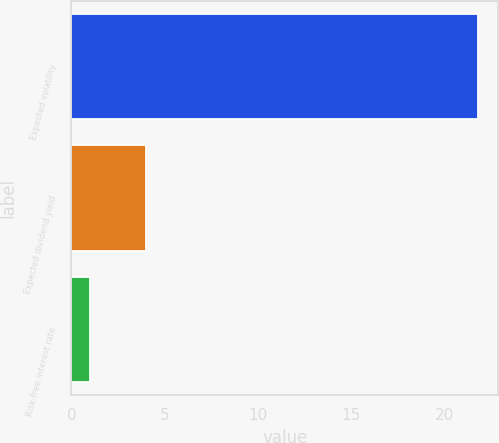<chart> <loc_0><loc_0><loc_500><loc_500><bar_chart><fcel>Expected volatility<fcel>Expected dividend yield<fcel>Risk-free interest rate<nl><fcel>21.8<fcel>4<fcel>1<nl></chart> 